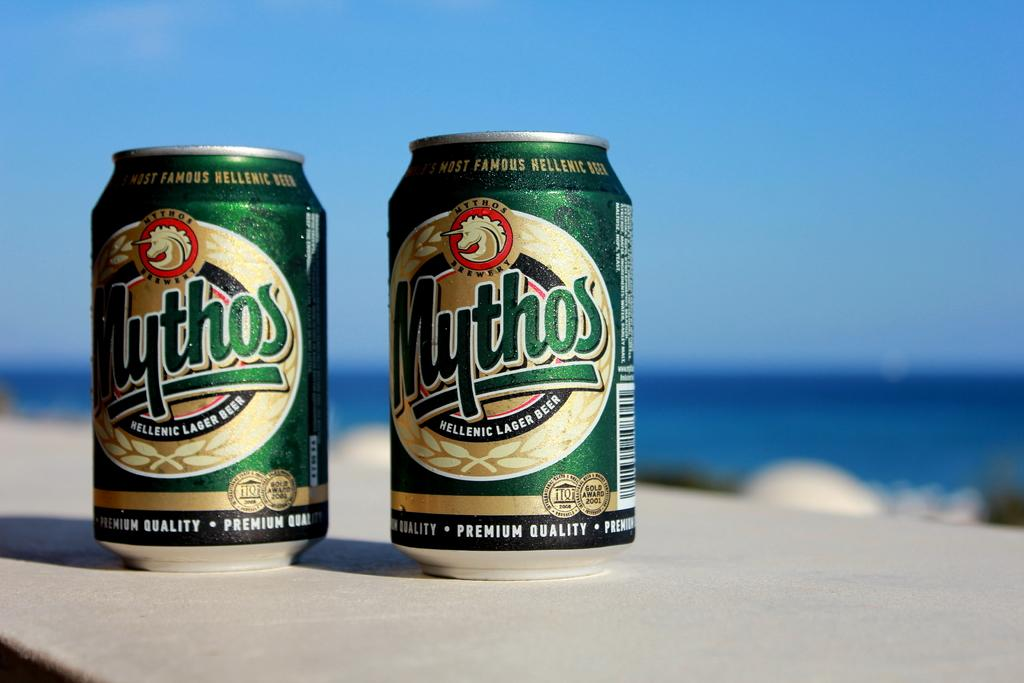<image>
Create a compact narrative representing the image presented. Two cans of hellenic lager beer are shown with a blue background. 